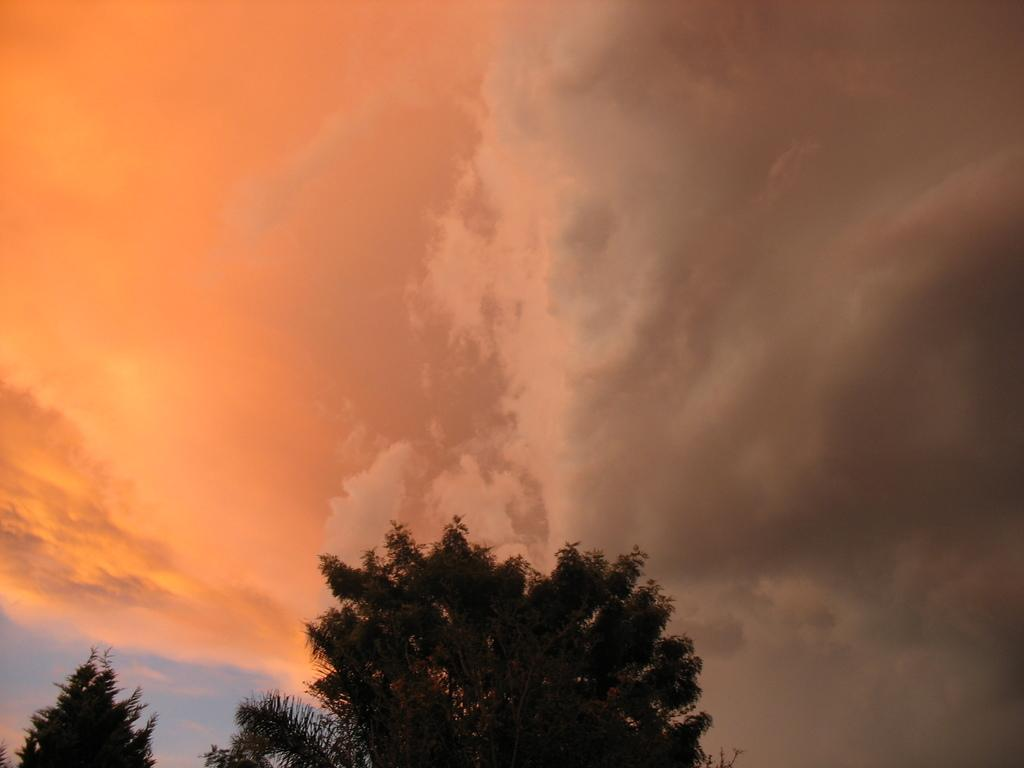What type of vegetation is present at the bottom of the image? There are trees at the bottom of the image. What can be seen in the sky in the image? There are clouds in the image. What part of the natural environment is visible in the image? The sky is visible in the image. What type of selection process is taking place in the image? There is no selection process present in the image; it features trees, clouds, and the sky. Can you hear any sounds in the image? The image is silent, as it is a visual representation and does not contain any audible elements. 